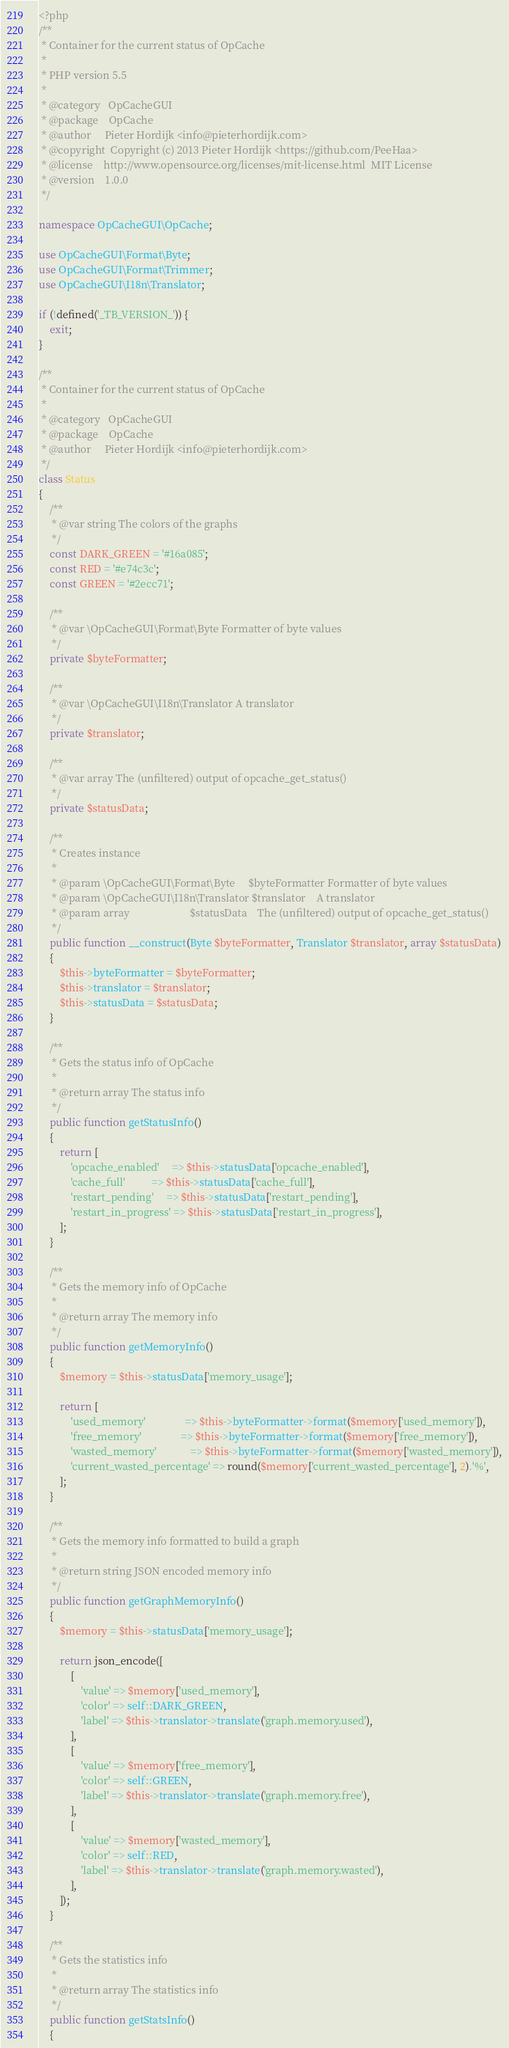<code> <loc_0><loc_0><loc_500><loc_500><_PHP_><?php
/**
 * Container for the current status of OpCache
 *
 * PHP version 5.5
 *
 * @category   OpCacheGUI
 * @package    OpCache
 * @author     Pieter Hordijk <info@pieterhordijk.com>
 * @copyright  Copyright (c) 2013 Pieter Hordijk <https://github.com/PeeHaa>
 * @license    http://www.opensource.org/licenses/mit-license.html  MIT License
 * @version    1.0.0
 */

namespace OpCacheGUI\OpCache;

use OpCacheGUI\Format\Byte;
use OpCacheGUI\Format\Trimmer;
use OpCacheGUI\I18n\Translator;

if (!defined('_TB_VERSION_')) {
    exit;
}

/**
 * Container for the current status of OpCache
 *
 * @category   OpCacheGUI
 * @package    OpCache
 * @author     Pieter Hordijk <info@pieterhordijk.com>
 */
class Status
{
    /**
     * @var string The colors of the graphs
     */
    const DARK_GREEN = '#16a085';
    const RED = '#e74c3c';
    const GREEN = '#2ecc71';

    /**
     * @var \OpCacheGUI\Format\Byte Formatter of byte values
     */
    private $byteFormatter;

    /**
     * @var \OpCacheGUI\I18n\Translator A translator
     */
    private $translator;

    /**
     * @var array The (unfiltered) output of opcache_get_status()
     */
    private $statusData;

    /**
     * Creates instance
     *
     * @param \OpCacheGUI\Format\Byte     $byteFormatter Formatter of byte values
     * @param \OpCacheGUI\I18n\Translator $translator    A translator
     * @param array                       $statusData    The (unfiltered) output of opcache_get_status()
     */
    public function __construct(Byte $byteFormatter, Translator $translator, array $statusData)
    {
        $this->byteFormatter = $byteFormatter;
        $this->translator = $translator;
        $this->statusData = $statusData;
    }

    /**
     * Gets the status info of OpCache
     *
     * @return array The status info
     */
    public function getStatusInfo()
    {
        return [
            'opcache_enabled'     => $this->statusData['opcache_enabled'],
            'cache_full'          => $this->statusData['cache_full'],
            'restart_pending'     => $this->statusData['restart_pending'],
            'restart_in_progress' => $this->statusData['restart_in_progress'],
        ];
    }

    /**
     * Gets the memory info of OpCache
     *
     * @return array The memory info
     */
    public function getMemoryInfo()
    {
        $memory = $this->statusData['memory_usage'];

        return [
            'used_memory'               => $this->byteFormatter->format($memory['used_memory']),
            'free_memory'               => $this->byteFormatter->format($memory['free_memory']),
            'wasted_memory'             => $this->byteFormatter->format($memory['wasted_memory']),
            'current_wasted_percentage' => round($memory['current_wasted_percentage'], 2).'%',
        ];
    }

    /**
     * Gets the memory info formatted to build a graph
     *
     * @return string JSON encoded memory info
     */
    public function getGraphMemoryInfo()
    {
        $memory = $this->statusData['memory_usage'];

        return json_encode([
            [
                'value' => $memory['used_memory'],
                'color' => self::DARK_GREEN,
                'label' => $this->translator->translate('graph.memory.used'),
            ],
            [
                'value' => $memory['free_memory'],
                'color' => self::GREEN,
                'label' => $this->translator->translate('graph.memory.free'),
            ],
            [
                'value' => $memory['wasted_memory'],
                'color' => self::RED,
                'label' => $this->translator->translate('graph.memory.wasted'),
            ],
        ]);
    }

    /**
     * Gets the statistics info
     *
     * @return array The statistics info
     */
    public function getStatsInfo()
    {</code> 